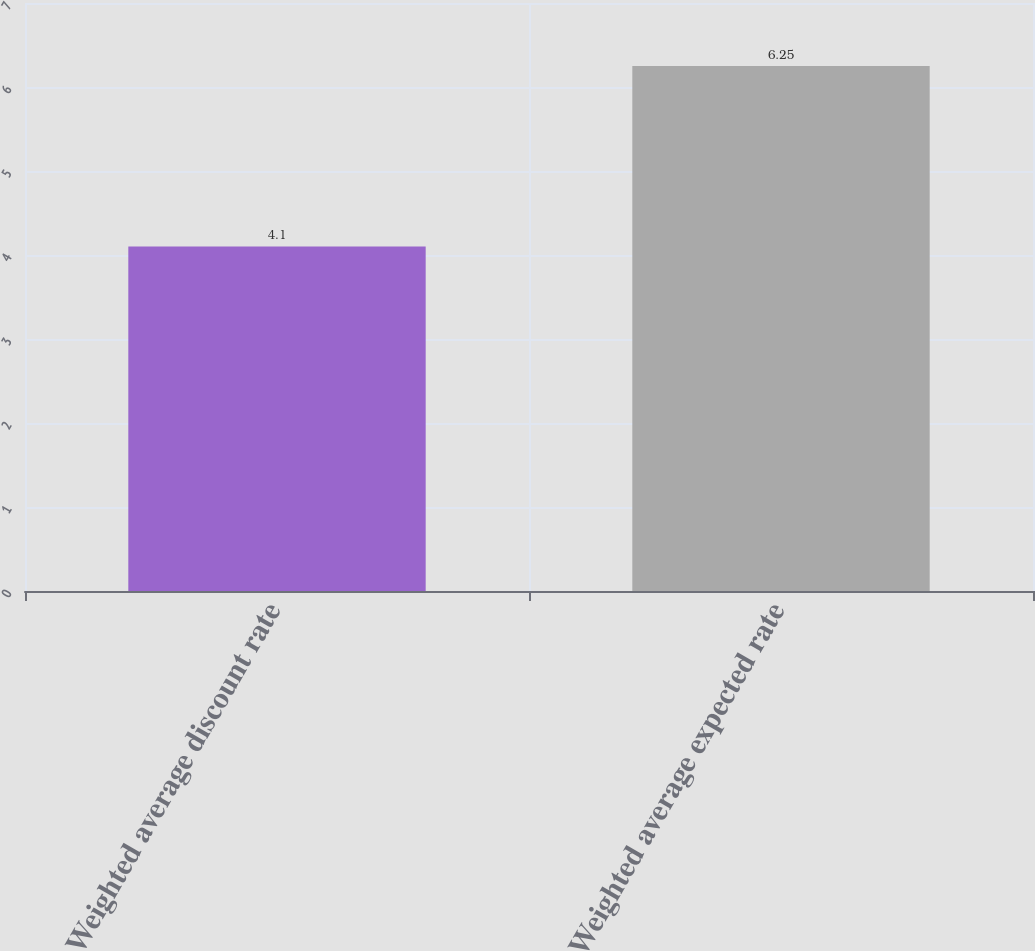<chart> <loc_0><loc_0><loc_500><loc_500><bar_chart><fcel>Weighted average discount rate<fcel>Weighted average expected rate<nl><fcel>4.1<fcel>6.25<nl></chart> 